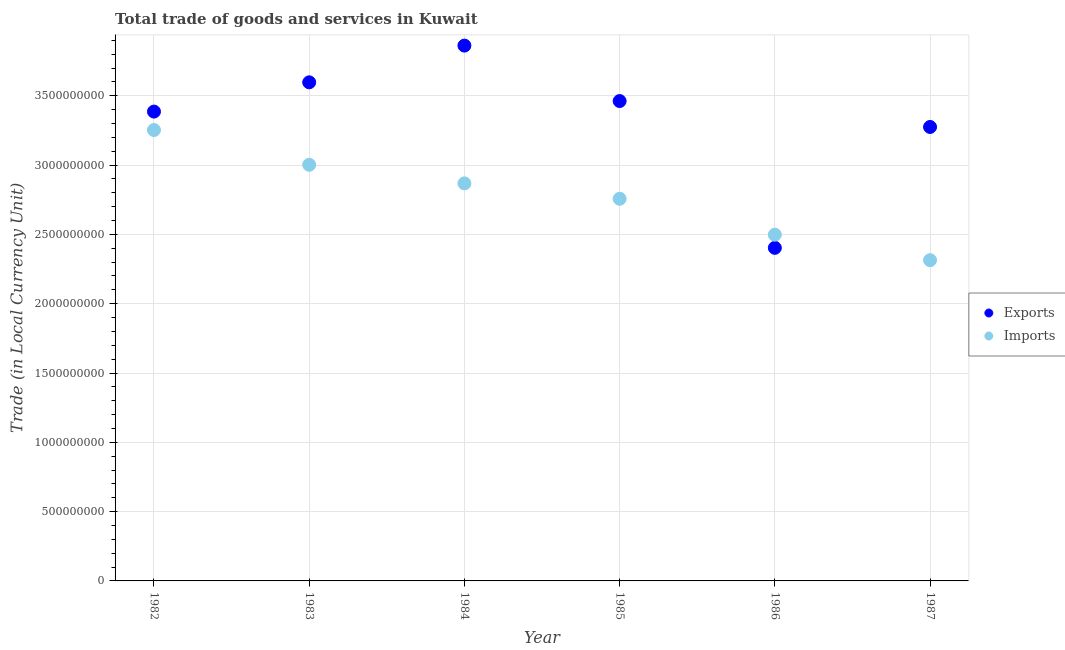Is the number of dotlines equal to the number of legend labels?
Give a very brief answer. Yes. What is the export of goods and services in 1982?
Your answer should be compact. 3.39e+09. Across all years, what is the maximum export of goods and services?
Provide a short and direct response. 3.86e+09. Across all years, what is the minimum imports of goods and services?
Your answer should be compact. 2.31e+09. What is the total imports of goods and services in the graph?
Give a very brief answer. 1.67e+1. What is the difference between the export of goods and services in 1986 and that in 1987?
Offer a terse response. -8.72e+08. What is the difference between the export of goods and services in 1985 and the imports of goods and services in 1983?
Your answer should be very brief. 4.60e+08. What is the average imports of goods and services per year?
Make the answer very short. 2.78e+09. In the year 1982, what is the difference between the export of goods and services and imports of goods and services?
Your response must be concise. 1.33e+08. What is the ratio of the imports of goods and services in 1983 to that in 1984?
Your answer should be very brief. 1.05. Is the export of goods and services in 1982 less than that in 1986?
Your response must be concise. No. What is the difference between the highest and the second highest export of goods and services?
Provide a succinct answer. 2.65e+08. What is the difference between the highest and the lowest export of goods and services?
Your answer should be very brief. 1.46e+09. In how many years, is the imports of goods and services greater than the average imports of goods and services taken over all years?
Give a very brief answer. 3. Is the export of goods and services strictly greater than the imports of goods and services over the years?
Offer a very short reply. No. Is the export of goods and services strictly less than the imports of goods and services over the years?
Offer a very short reply. No. How many years are there in the graph?
Your answer should be compact. 6. Are the values on the major ticks of Y-axis written in scientific E-notation?
Make the answer very short. No. Does the graph contain any zero values?
Your answer should be very brief. No. What is the title of the graph?
Make the answer very short. Total trade of goods and services in Kuwait. Does "Ages 15-24" appear as one of the legend labels in the graph?
Your answer should be compact. No. What is the label or title of the X-axis?
Offer a terse response. Year. What is the label or title of the Y-axis?
Give a very brief answer. Trade (in Local Currency Unit). What is the Trade (in Local Currency Unit) of Exports in 1982?
Your answer should be very brief. 3.39e+09. What is the Trade (in Local Currency Unit) in Imports in 1982?
Keep it short and to the point. 3.25e+09. What is the Trade (in Local Currency Unit) of Exports in 1983?
Offer a terse response. 3.60e+09. What is the Trade (in Local Currency Unit) of Imports in 1983?
Offer a very short reply. 3.00e+09. What is the Trade (in Local Currency Unit) of Exports in 1984?
Make the answer very short. 3.86e+09. What is the Trade (in Local Currency Unit) in Imports in 1984?
Offer a very short reply. 2.87e+09. What is the Trade (in Local Currency Unit) of Exports in 1985?
Offer a very short reply. 3.46e+09. What is the Trade (in Local Currency Unit) of Imports in 1985?
Provide a succinct answer. 2.76e+09. What is the Trade (in Local Currency Unit) of Exports in 1986?
Give a very brief answer. 2.40e+09. What is the Trade (in Local Currency Unit) in Imports in 1986?
Keep it short and to the point. 2.50e+09. What is the Trade (in Local Currency Unit) of Exports in 1987?
Your answer should be very brief. 3.28e+09. What is the Trade (in Local Currency Unit) in Imports in 1987?
Your response must be concise. 2.31e+09. Across all years, what is the maximum Trade (in Local Currency Unit) of Exports?
Make the answer very short. 3.86e+09. Across all years, what is the maximum Trade (in Local Currency Unit) in Imports?
Your response must be concise. 3.25e+09. Across all years, what is the minimum Trade (in Local Currency Unit) of Exports?
Give a very brief answer. 2.40e+09. Across all years, what is the minimum Trade (in Local Currency Unit) in Imports?
Offer a very short reply. 2.31e+09. What is the total Trade (in Local Currency Unit) in Exports in the graph?
Offer a very short reply. 2.00e+1. What is the total Trade (in Local Currency Unit) of Imports in the graph?
Make the answer very short. 1.67e+1. What is the difference between the Trade (in Local Currency Unit) in Exports in 1982 and that in 1983?
Provide a short and direct response. -2.11e+08. What is the difference between the Trade (in Local Currency Unit) of Imports in 1982 and that in 1983?
Ensure brevity in your answer.  2.51e+08. What is the difference between the Trade (in Local Currency Unit) in Exports in 1982 and that in 1984?
Your answer should be very brief. -4.76e+08. What is the difference between the Trade (in Local Currency Unit) in Imports in 1982 and that in 1984?
Keep it short and to the point. 3.85e+08. What is the difference between the Trade (in Local Currency Unit) of Exports in 1982 and that in 1985?
Give a very brief answer. -7.60e+07. What is the difference between the Trade (in Local Currency Unit) of Imports in 1982 and that in 1985?
Ensure brevity in your answer.  4.96e+08. What is the difference between the Trade (in Local Currency Unit) of Exports in 1982 and that in 1986?
Offer a terse response. 9.83e+08. What is the difference between the Trade (in Local Currency Unit) of Imports in 1982 and that in 1986?
Your response must be concise. 7.55e+08. What is the difference between the Trade (in Local Currency Unit) in Exports in 1982 and that in 1987?
Offer a terse response. 1.11e+08. What is the difference between the Trade (in Local Currency Unit) of Imports in 1982 and that in 1987?
Your answer should be very brief. 9.39e+08. What is the difference between the Trade (in Local Currency Unit) in Exports in 1983 and that in 1984?
Your answer should be compact. -2.65e+08. What is the difference between the Trade (in Local Currency Unit) in Imports in 1983 and that in 1984?
Make the answer very short. 1.34e+08. What is the difference between the Trade (in Local Currency Unit) of Exports in 1983 and that in 1985?
Your answer should be compact. 1.35e+08. What is the difference between the Trade (in Local Currency Unit) of Imports in 1983 and that in 1985?
Your answer should be compact. 2.45e+08. What is the difference between the Trade (in Local Currency Unit) of Exports in 1983 and that in 1986?
Your response must be concise. 1.19e+09. What is the difference between the Trade (in Local Currency Unit) in Imports in 1983 and that in 1986?
Keep it short and to the point. 5.04e+08. What is the difference between the Trade (in Local Currency Unit) in Exports in 1983 and that in 1987?
Your answer should be very brief. 3.22e+08. What is the difference between the Trade (in Local Currency Unit) in Imports in 1983 and that in 1987?
Your answer should be compact. 6.88e+08. What is the difference between the Trade (in Local Currency Unit) of Exports in 1984 and that in 1985?
Offer a terse response. 4.00e+08. What is the difference between the Trade (in Local Currency Unit) of Imports in 1984 and that in 1985?
Your answer should be compact. 1.11e+08. What is the difference between the Trade (in Local Currency Unit) in Exports in 1984 and that in 1986?
Keep it short and to the point. 1.46e+09. What is the difference between the Trade (in Local Currency Unit) in Imports in 1984 and that in 1986?
Provide a short and direct response. 3.70e+08. What is the difference between the Trade (in Local Currency Unit) of Exports in 1984 and that in 1987?
Keep it short and to the point. 5.87e+08. What is the difference between the Trade (in Local Currency Unit) of Imports in 1984 and that in 1987?
Offer a terse response. 5.54e+08. What is the difference between the Trade (in Local Currency Unit) of Exports in 1985 and that in 1986?
Keep it short and to the point. 1.06e+09. What is the difference between the Trade (in Local Currency Unit) of Imports in 1985 and that in 1986?
Your answer should be very brief. 2.59e+08. What is the difference between the Trade (in Local Currency Unit) in Exports in 1985 and that in 1987?
Your answer should be compact. 1.87e+08. What is the difference between the Trade (in Local Currency Unit) of Imports in 1985 and that in 1987?
Provide a succinct answer. 4.43e+08. What is the difference between the Trade (in Local Currency Unit) of Exports in 1986 and that in 1987?
Offer a very short reply. -8.72e+08. What is the difference between the Trade (in Local Currency Unit) in Imports in 1986 and that in 1987?
Provide a succinct answer. 1.84e+08. What is the difference between the Trade (in Local Currency Unit) of Exports in 1982 and the Trade (in Local Currency Unit) of Imports in 1983?
Keep it short and to the point. 3.84e+08. What is the difference between the Trade (in Local Currency Unit) in Exports in 1982 and the Trade (in Local Currency Unit) in Imports in 1984?
Give a very brief answer. 5.18e+08. What is the difference between the Trade (in Local Currency Unit) of Exports in 1982 and the Trade (in Local Currency Unit) of Imports in 1985?
Offer a terse response. 6.29e+08. What is the difference between the Trade (in Local Currency Unit) in Exports in 1982 and the Trade (in Local Currency Unit) in Imports in 1986?
Make the answer very short. 8.88e+08. What is the difference between the Trade (in Local Currency Unit) in Exports in 1982 and the Trade (in Local Currency Unit) in Imports in 1987?
Provide a succinct answer. 1.07e+09. What is the difference between the Trade (in Local Currency Unit) in Exports in 1983 and the Trade (in Local Currency Unit) in Imports in 1984?
Offer a terse response. 7.29e+08. What is the difference between the Trade (in Local Currency Unit) of Exports in 1983 and the Trade (in Local Currency Unit) of Imports in 1985?
Your answer should be compact. 8.40e+08. What is the difference between the Trade (in Local Currency Unit) of Exports in 1983 and the Trade (in Local Currency Unit) of Imports in 1986?
Offer a very short reply. 1.10e+09. What is the difference between the Trade (in Local Currency Unit) in Exports in 1983 and the Trade (in Local Currency Unit) in Imports in 1987?
Your response must be concise. 1.28e+09. What is the difference between the Trade (in Local Currency Unit) of Exports in 1984 and the Trade (in Local Currency Unit) of Imports in 1985?
Make the answer very short. 1.11e+09. What is the difference between the Trade (in Local Currency Unit) of Exports in 1984 and the Trade (in Local Currency Unit) of Imports in 1986?
Your answer should be very brief. 1.36e+09. What is the difference between the Trade (in Local Currency Unit) of Exports in 1984 and the Trade (in Local Currency Unit) of Imports in 1987?
Provide a succinct answer. 1.55e+09. What is the difference between the Trade (in Local Currency Unit) in Exports in 1985 and the Trade (in Local Currency Unit) in Imports in 1986?
Make the answer very short. 9.64e+08. What is the difference between the Trade (in Local Currency Unit) of Exports in 1985 and the Trade (in Local Currency Unit) of Imports in 1987?
Offer a terse response. 1.15e+09. What is the difference between the Trade (in Local Currency Unit) of Exports in 1986 and the Trade (in Local Currency Unit) of Imports in 1987?
Your answer should be compact. 8.90e+07. What is the average Trade (in Local Currency Unit) of Exports per year?
Make the answer very short. 3.33e+09. What is the average Trade (in Local Currency Unit) in Imports per year?
Your answer should be very brief. 2.78e+09. In the year 1982, what is the difference between the Trade (in Local Currency Unit) in Exports and Trade (in Local Currency Unit) in Imports?
Offer a very short reply. 1.33e+08. In the year 1983, what is the difference between the Trade (in Local Currency Unit) in Exports and Trade (in Local Currency Unit) in Imports?
Your response must be concise. 5.95e+08. In the year 1984, what is the difference between the Trade (in Local Currency Unit) of Exports and Trade (in Local Currency Unit) of Imports?
Your response must be concise. 9.94e+08. In the year 1985, what is the difference between the Trade (in Local Currency Unit) of Exports and Trade (in Local Currency Unit) of Imports?
Give a very brief answer. 7.05e+08. In the year 1986, what is the difference between the Trade (in Local Currency Unit) of Exports and Trade (in Local Currency Unit) of Imports?
Your answer should be compact. -9.50e+07. In the year 1987, what is the difference between the Trade (in Local Currency Unit) in Exports and Trade (in Local Currency Unit) in Imports?
Provide a succinct answer. 9.61e+08. What is the ratio of the Trade (in Local Currency Unit) of Exports in 1982 to that in 1983?
Make the answer very short. 0.94. What is the ratio of the Trade (in Local Currency Unit) in Imports in 1982 to that in 1983?
Your answer should be very brief. 1.08. What is the ratio of the Trade (in Local Currency Unit) in Exports in 1982 to that in 1984?
Offer a terse response. 0.88. What is the ratio of the Trade (in Local Currency Unit) of Imports in 1982 to that in 1984?
Ensure brevity in your answer.  1.13. What is the ratio of the Trade (in Local Currency Unit) in Imports in 1982 to that in 1985?
Your answer should be compact. 1.18. What is the ratio of the Trade (in Local Currency Unit) in Exports in 1982 to that in 1986?
Your answer should be very brief. 1.41. What is the ratio of the Trade (in Local Currency Unit) in Imports in 1982 to that in 1986?
Keep it short and to the point. 1.3. What is the ratio of the Trade (in Local Currency Unit) in Exports in 1982 to that in 1987?
Provide a short and direct response. 1.03. What is the ratio of the Trade (in Local Currency Unit) of Imports in 1982 to that in 1987?
Make the answer very short. 1.41. What is the ratio of the Trade (in Local Currency Unit) in Exports in 1983 to that in 1984?
Provide a short and direct response. 0.93. What is the ratio of the Trade (in Local Currency Unit) in Imports in 1983 to that in 1984?
Keep it short and to the point. 1.05. What is the ratio of the Trade (in Local Currency Unit) of Exports in 1983 to that in 1985?
Your answer should be compact. 1.04. What is the ratio of the Trade (in Local Currency Unit) in Imports in 1983 to that in 1985?
Your answer should be very brief. 1.09. What is the ratio of the Trade (in Local Currency Unit) of Exports in 1983 to that in 1986?
Provide a succinct answer. 1.5. What is the ratio of the Trade (in Local Currency Unit) of Imports in 1983 to that in 1986?
Provide a short and direct response. 1.2. What is the ratio of the Trade (in Local Currency Unit) in Exports in 1983 to that in 1987?
Your answer should be compact. 1.1. What is the ratio of the Trade (in Local Currency Unit) in Imports in 1983 to that in 1987?
Offer a terse response. 1.3. What is the ratio of the Trade (in Local Currency Unit) in Exports in 1984 to that in 1985?
Offer a very short reply. 1.12. What is the ratio of the Trade (in Local Currency Unit) in Imports in 1984 to that in 1985?
Offer a terse response. 1.04. What is the ratio of the Trade (in Local Currency Unit) of Exports in 1984 to that in 1986?
Ensure brevity in your answer.  1.61. What is the ratio of the Trade (in Local Currency Unit) of Imports in 1984 to that in 1986?
Offer a terse response. 1.15. What is the ratio of the Trade (in Local Currency Unit) of Exports in 1984 to that in 1987?
Ensure brevity in your answer.  1.18. What is the ratio of the Trade (in Local Currency Unit) in Imports in 1984 to that in 1987?
Your answer should be compact. 1.24. What is the ratio of the Trade (in Local Currency Unit) in Exports in 1985 to that in 1986?
Ensure brevity in your answer.  1.44. What is the ratio of the Trade (in Local Currency Unit) of Imports in 1985 to that in 1986?
Your answer should be compact. 1.1. What is the ratio of the Trade (in Local Currency Unit) of Exports in 1985 to that in 1987?
Keep it short and to the point. 1.06. What is the ratio of the Trade (in Local Currency Unit) of Imports in 1985 to that in 1987?
Your answer should be very brief. 1.19. What is the ratio of the Trade (in Local Currency Unit) in Exports in 1986 to that in 1987?
Your answer should be very brief. 0.73. What is the ratio of the Trade (in Local Currency Unit) of Imports in 1986 to that in 1987?
Your answer should be very brief. 1.08. What is the difference between the highest and the second highest Trade (in Local Currency Unit) in Exports?
Give a very brief answer. 2.65e+08. What is the difference between the highest and the second highest Trade (in Local Currency Unit) of Imports?
Offer a terse response. 2.51e+08. What is the difference between the highest and the lowest Trade (in Local Currency Unit) in Exports?
Ensure brevity in your answer.  1.46e+09. What is the difference between the highest and the lowest Trade (in Local Currency Unit) of Imports?
Provide a short and direct response. 9.39e+08. 